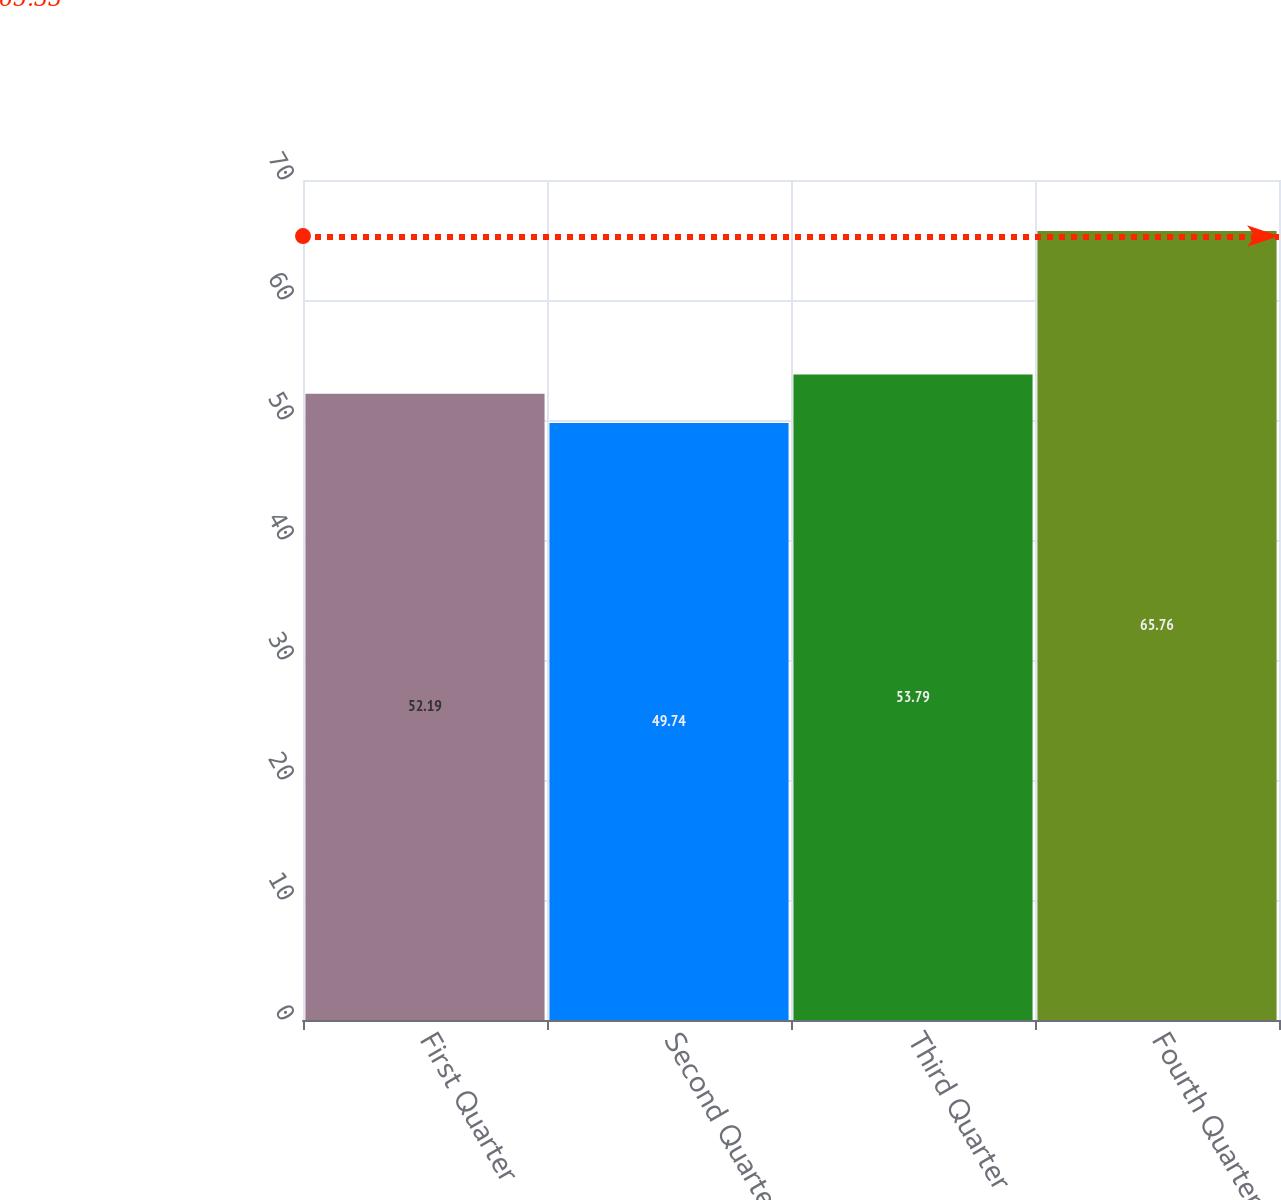Convert chart to OTSL. <chart><loc_0><loc_0><loc_500><loc_500><bar_chart><fcel>First Quarter<fcel>Second Quarter<fcel>Third Quarter<fcel>Fourth Quarter<nl><fcel>52.19<fcel>49.74<fcel>53.79<fcel>65.76<nl></chart> 